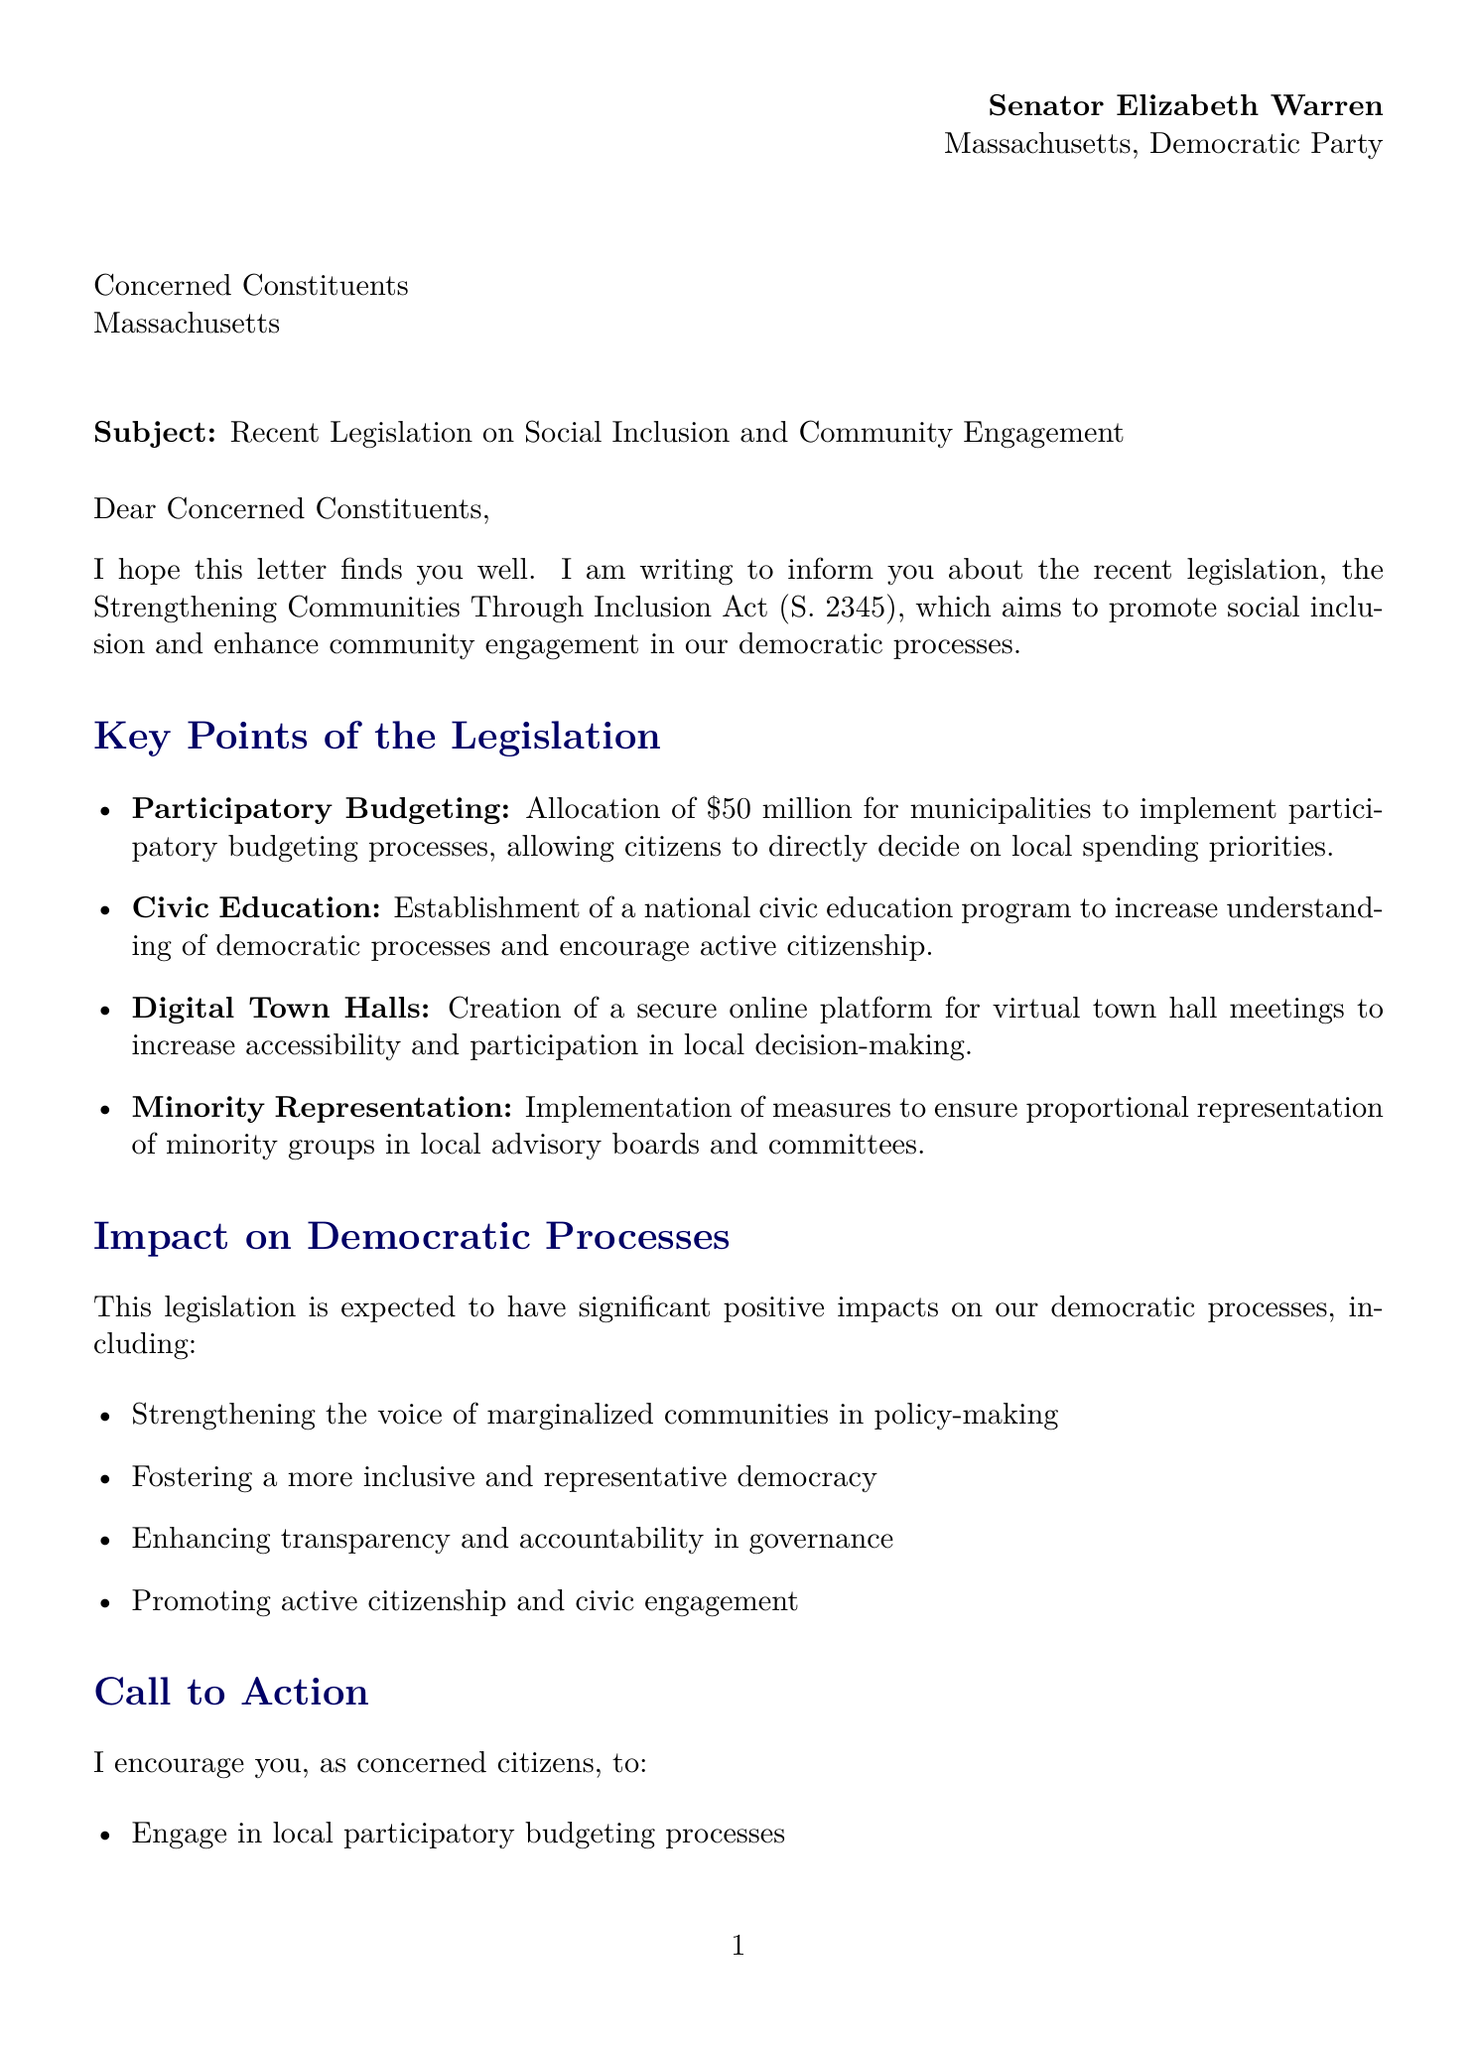What is the name of the legislation? The letter mentions a specific piece of legislation which is named the Strengthening Communities Through Inclusion Act.
Answer: Strengthening Communities Through Inclusion Act What is the bill number for the legislation? The document provides the specific bill number associated with the legislation, which is S. 2345.
Answer: S. 2345 How much funding is allocated for participatory budgeting? The letter states that the funding allocated for participatory budgeting processes is 50 million dollars.
Answer: $50 million What is one objective of the legislation? The legislation has several objectives, one of which is to promote diversity and inclusion in local governance.
Answer: Promote diversity and inclusion in local governance What challenge is mentioned regarding digital platforms? The document highlights a challenge related to digital platforms, specifically ensuring equitable access to them.
Answer: Ensuring equitable access to digital platforms Who is the sender of the letter? The sender of the letter is identified as Senator Elizabeth Warren.
Answer: Senator Elizabeth Warren What is a call to action for constituents? The document encourages constituents to engage in local participatory budgeting processes as part of the call to action.
Answer: Engage in local participatory budgeting processes What impact does the legislation aim to have on policy-making? The legislations aims to strengthen the voice of marginalized communities in policy-making as part of its impact.
Answer: Strengthening the voice of marginalized communities in policy-making What organization is mentioned for supporting democratic reforms? The letter lists the Brennan Center for Justice as an organization providing research and advocacy support for democratic reforms.
Answer: Brennan Center for Justice 